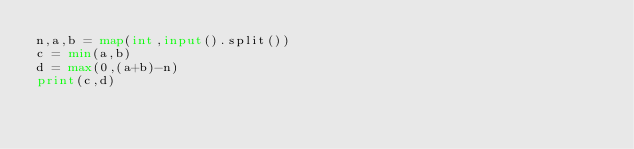Convert code to text. <code><loc_0><loc_0><loc_500><loc_500><_Python_>n,a,b = map(int,input().split())
c = min(a,b)
d = max(0,(a+b)-n)
print(c,d)</code> 